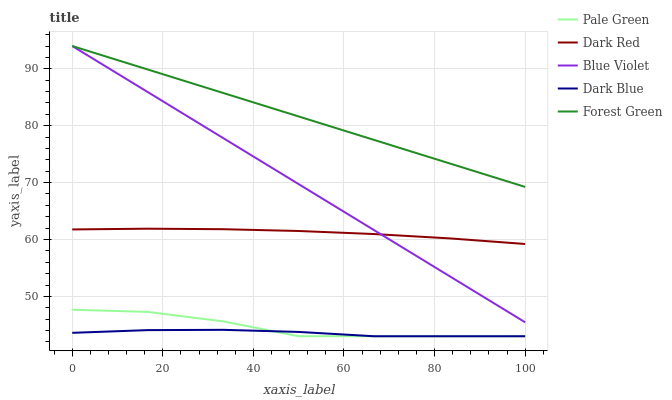Does Dark Blue have the minimum area under the curve?
Answer yes or no. Yes. Does Forest Green have the maximum area under the curve?
Answer yes or no. Yes. Does Pale Green have the minimum area under the curve?
Answer yes or no. No. Does Pale Green have the maximum area under the curve?
Answer yes or no. No. Is Forest Green the smoothest?
Answer yes or no. Yes. Is Pale Green the roughest?
Answer yes or no. Yes. Is Pale Green the smoothest?
Answer yes or no. No. Is Forest Green the roughest?
Answer yes or no. No. Does Pale Green have the lowest value?
Answer yes or no. Yes. Does Forest Green have the lowest value?
Answer yes or no. No. Does Blue Violet have the highest value?
Answer yes or no. Yes. Does Pale Green have the highest value?
Answer yes or no. No. Is Pale Green less than Blue Violet?
Answer yes or no. Yes. Is Forest Green greater than Dark Red?
Answer yes or no. Yes. Does Pale Green intersect Dark Blue?
Answer yes or no. Yes. Is Pale Green less than Dark Blue?
Answer yes or no. No. Is Pale Green greater than Dark Blue?
Answer yes or no. No. Does Pale Green intersect Blue Violet?
Answer yes or no. No. 